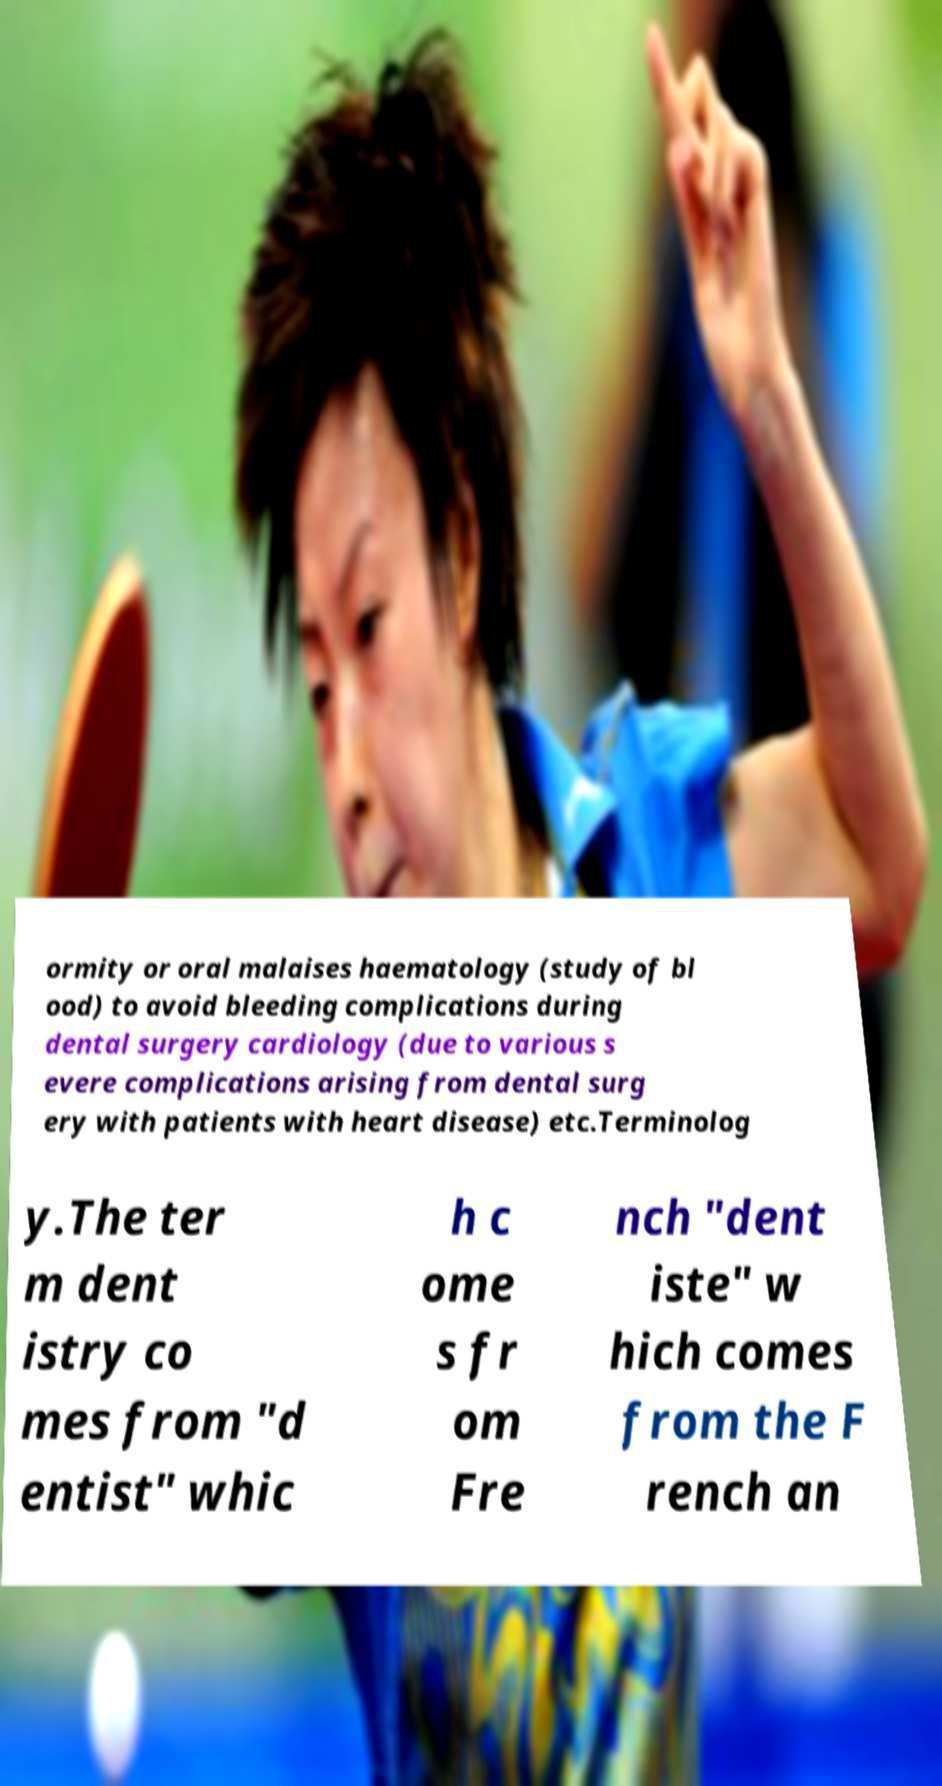For documentation purposes, I need the text within this image transcribed. Could you provide that? ormity or oral malaises haematology (study of bl ood) to avoid bleeding complications during dental surgery cardiology (due to various s evere complications arising from dental surg ery with patients with heart disease) etc.Terminolog y.The ter m dent istry co mes from "d entist" whic h c ome s fr om Fre nch "dent iste" w hich comes from the F rench an 